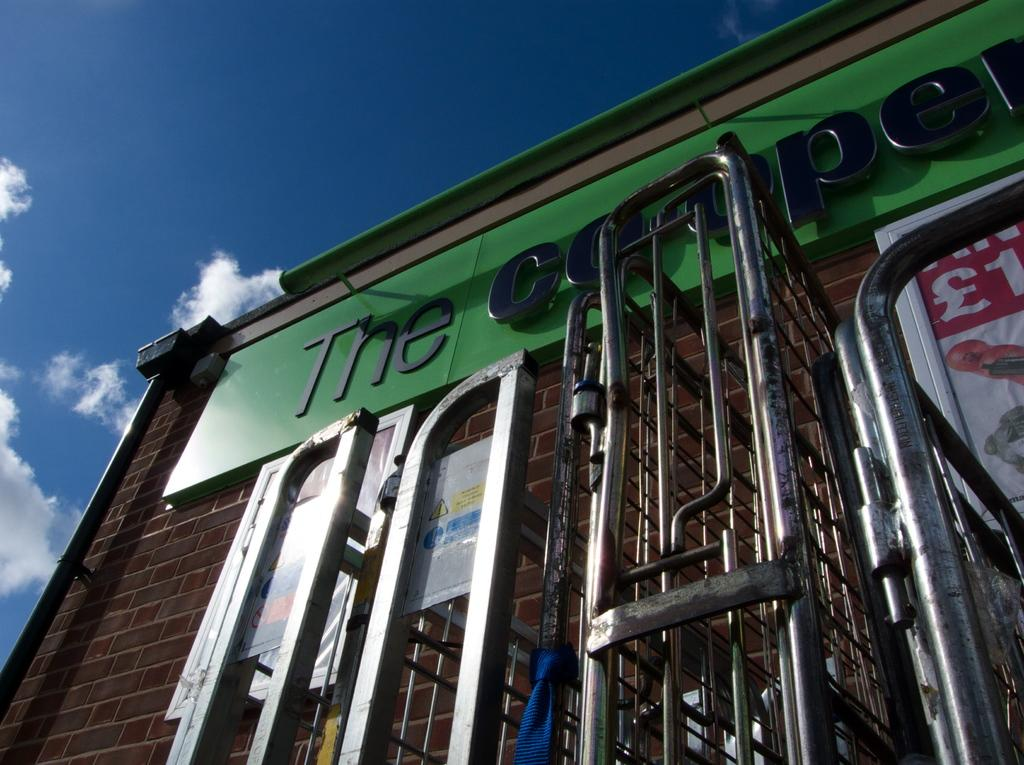<image>
Present a compact description of the photo's key features. The Cooper sign on a building written in black. 